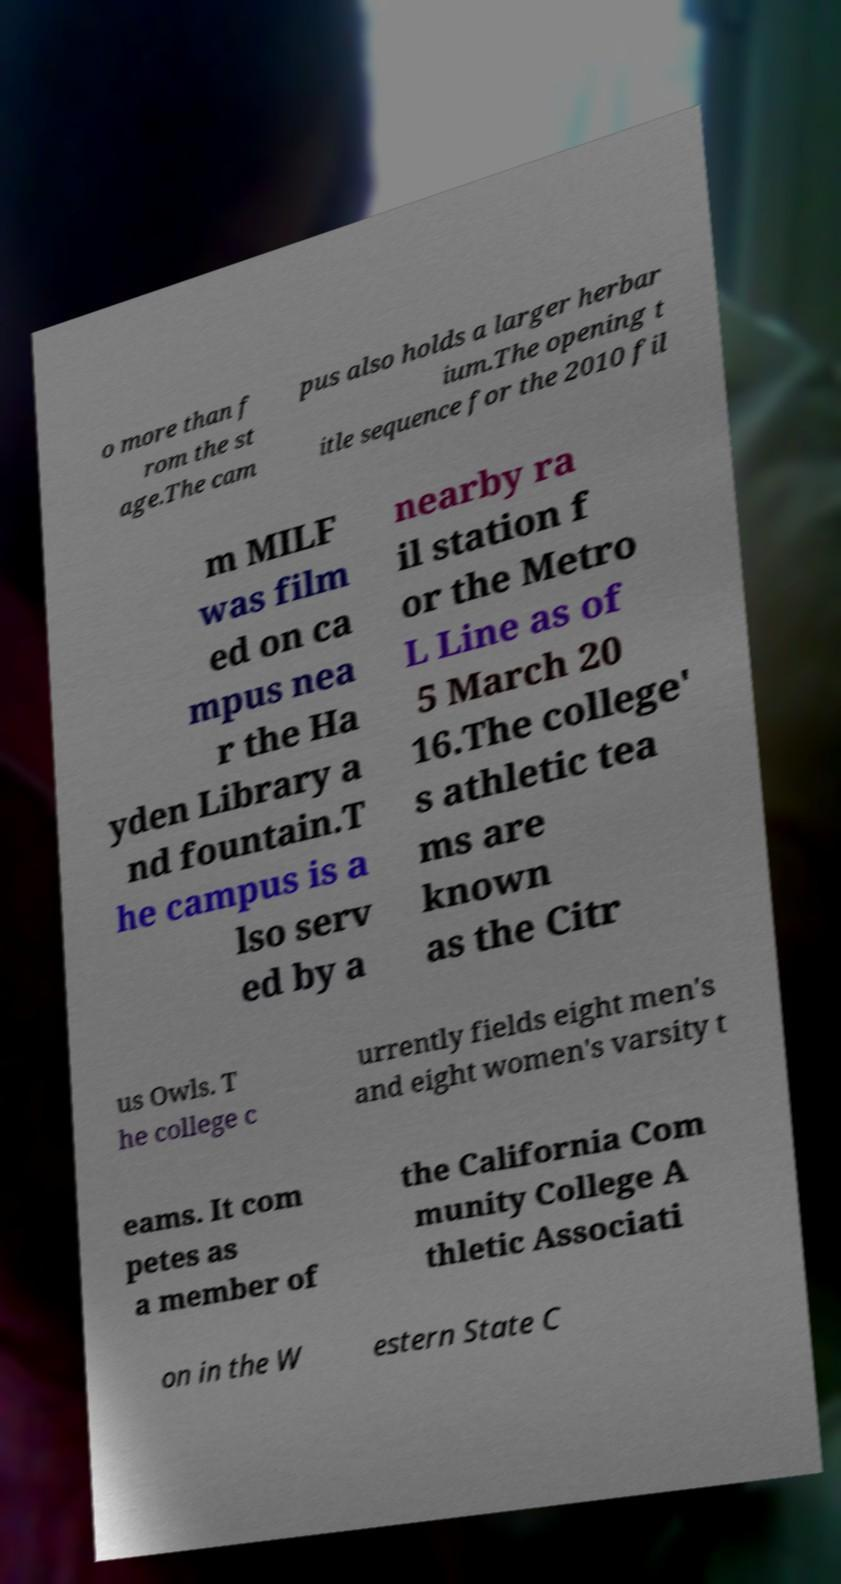For documentation purposes, I need the text within this image transcribed. Could you provide that? o more than f rom the st age.The cam pus also holds a larger herbar ium.The opening t itle sequence for the 2010 fil m MILF was film ed on ca mpus nea r the Ha yden Library a nd fountain.T he campus is a lso serv ed by a nearby ra il station f or the Metro L Line as of 5 March 20 16.The college' s athletic tea ms are known as the Citr us Owls. T he college c urrently fields eight men's and eight women's varsity t eams. It com petes as a member of the California Com munity College A thletic Associati on in the W estern State C 